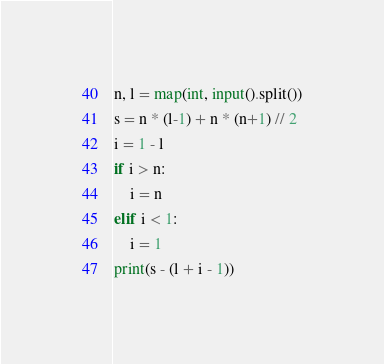Convert code to text. <code><loc_0><loc_0><loc_500><loc_500><_Python_>n, l = map(int, input().split())
s = n * (l-1) + n * (n+1) // 2
i = 1 - l
if i > n:
	i = n
elif i < 1:
  	i = 1
print(s - (l + i - 1))</code> 